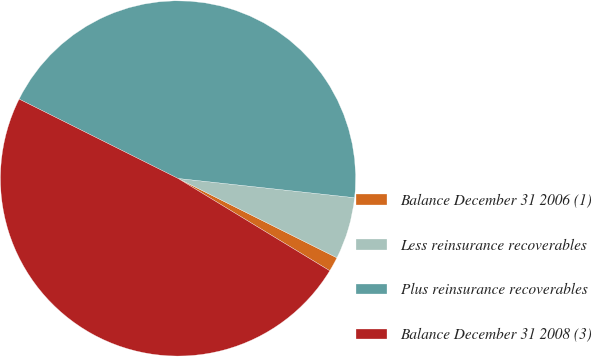Convert chart to OTSL. <chart><loc_0><loc_0><loc_500><loc_500><pie_chart><fcel>Balance December 31 2006 (1)<fcel>Less reinsurance recoverables<fcel>Plus reinsurance recoverables<fcel>Balance December 31 2008 (3)<nl><fcel>1.33%<fcel>5.64%<fcel>44.36%<fcel>48.67%<nl></chart> 